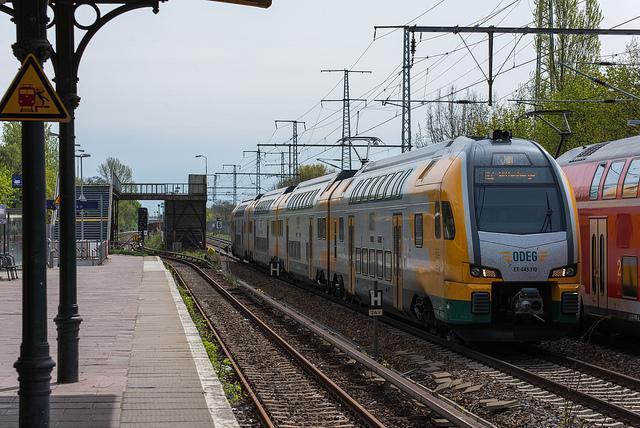How many trains are in the picture?
Give a very brief answer. 2. How many tracks?
Give a very brief answer. 3. How many trains are there?
Give a very brief answer. 2. How many decks does the yellow bus have?
Give a very brief answer. 0. 